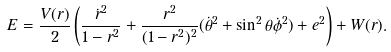<formula> <loc_0><loc_0><loc_500><loc_500>E = \frac { V ( r ) } { 2 } \left ( \frac { \dot { r } ^ { 2 } } { 1 - r ^ { 2 } } + \frac { r ^ { 2 } } { ( 1 - r ^ { 2 } ) ^ { 2 } } ( \dot { \theta } ^ { 2 } + \sin ^ { 2 } \theta \dot { \phi } ^ { 2 } ) + e ^ { 2 } \right ) + W ( r ) .</formula> 